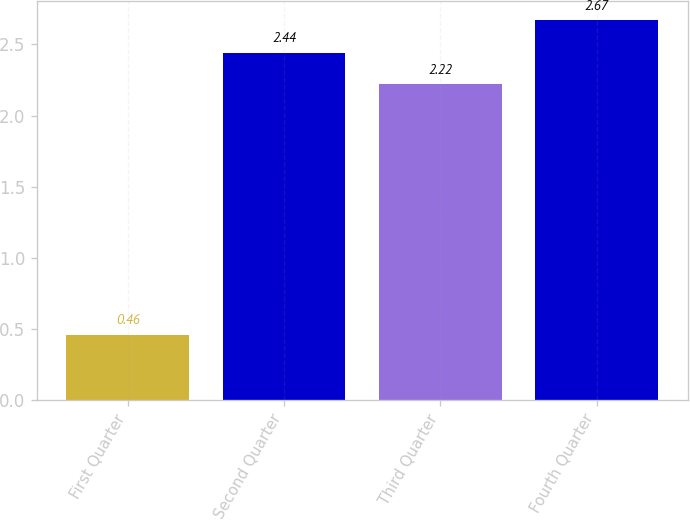Convert chart to OTSL. <chart><loc_0><loc_0><loc_500><loc_500><bar_chart><fcel>First Quarter<fcel>Second Quarter<fcel>Third Quarter<fcel>Fourth Quarter<nl><fcel>0.46<fcel>2.44<fcel>2.22<fcel>2.67<nl></chart> 